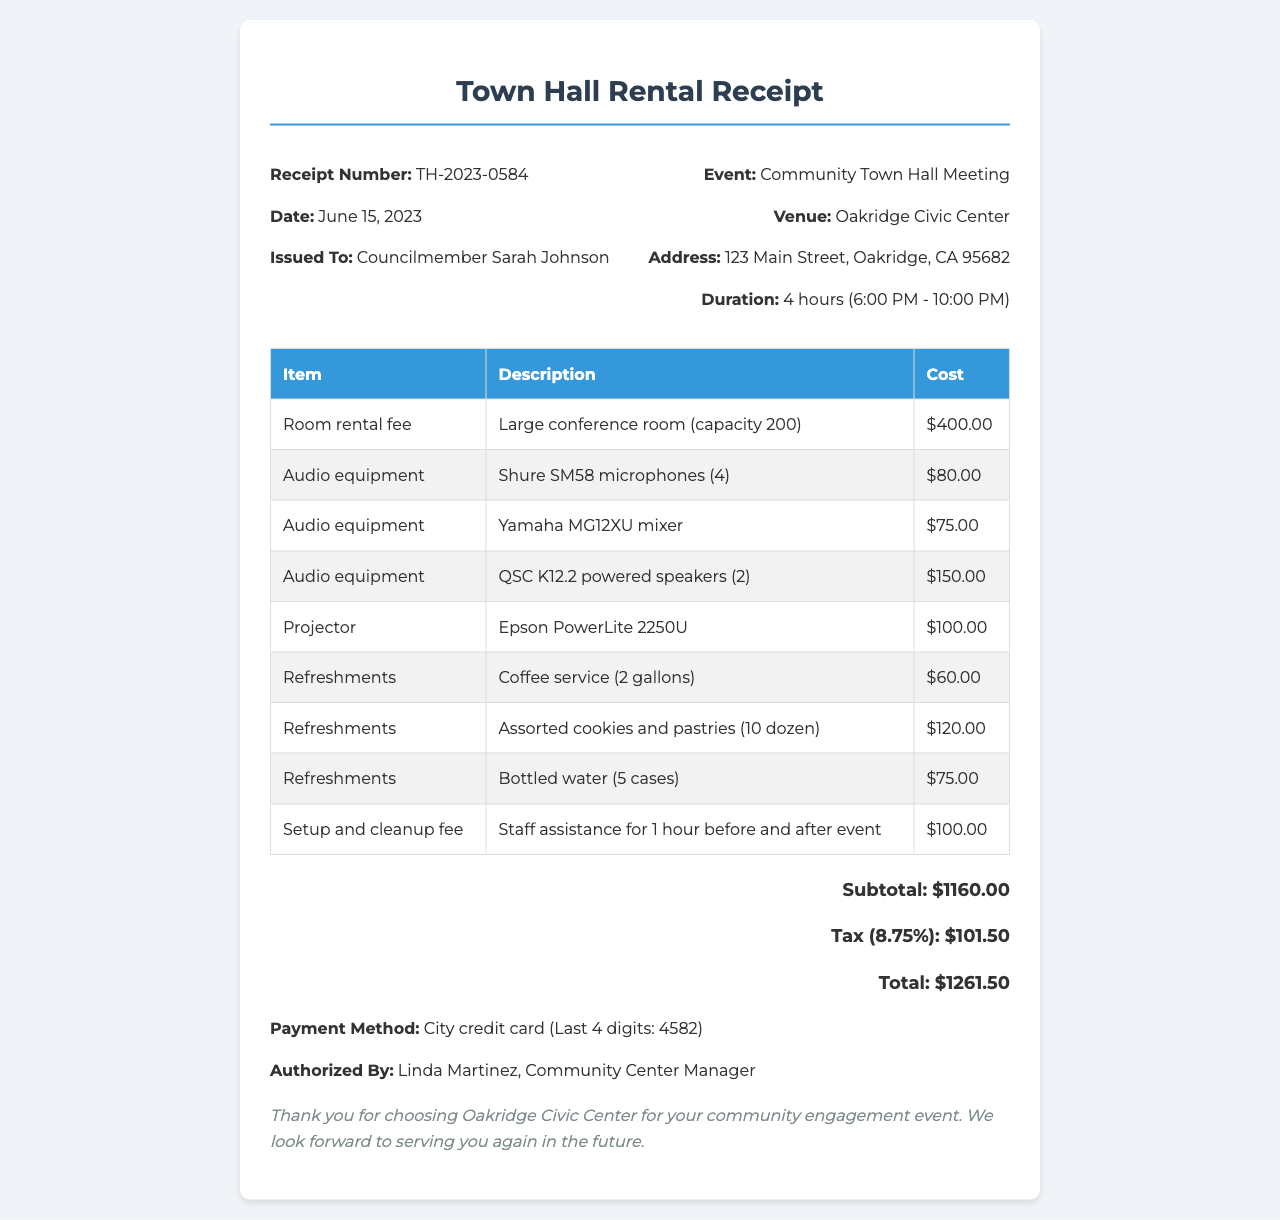What is the receipt number? The receipt number is stated clearly in the document and helps identify the transaction, which is TH-2023-0584.
Answer: TH-2023-0584 What is the total amount charged? The total amount is the sum after applying the tax to the subtotal, which is $1160.00 + $101.50 = $1261.50.
Answer: $1261.50 Who was the receipt issued to? The document specifies the person to whom the receipt is issued, identified as Councilmember Sarah Johnson.
Answer: Councilmember Sarah Johnson What date was the receipt issued? The date of the receipt shows when the transaction occurred, which is June 15, 2023.
Answer: June 15, 2023 How much did the audio equipment cost in total? The total cost for audio equipment can be calculated by adding the individual costs: $80.00 + $75.00 + $150.00 = $305.00.
Answer: $305.00 What items were included in the refreshments? The document lists the refreshments that include coffee service, assorted cookies and pastries, and bottled water.
Answer: Coffee service, assorted cookies and pastries, bottled water What was the duration of the rental? The rental duration is specified in the document as 4 hours, from 6:00 PM to 10:00 PM.
Answer: 4 hours (6:00 PM - 10:00 PM) Would you find any notes at the bottom of the receipt? The receipt contains a notes section, which usually includes any remarks related to the service or gratitude.
Answer: Thank you for choosing Oakridge Civic Center for your community engagement event. We look forward to serving you again in the future Who authorized the payment? The authorization of the payment is provided in the document, showing that Linda Martinez, Community Center Manager, was responsible for it.
Answer: Linda Martinez, Community Center Manager 